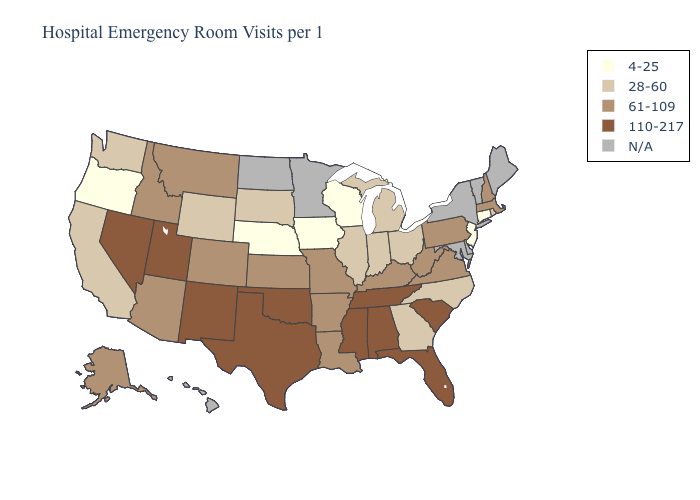What is the lowest value in the South?
Write a very short answer. 28-60. How many symbols are there in the legend?
Write a very short answer. 5. Name the states that have a value in the range 61-109?
Quick response, please. Alaska, Arizona, Arkansas, Colorado, Idaho, Kansas, Kentucky, Louisiana, Massachusetts, Missouri, Montana, New Hampshire, Pennsylvania, Virginia, West Virginia. Among the states that border Missouri , which have the lowest value?
Write a very short answer. Iowa, Nebraska. Does Pennsylvania have the highest value in the Northeast?
Be succinct. Yes. What is the value of California?
Write a very short answer. 28-60. Is the legend a continuous bar?
Write a very short answer. No. Name the states that have a value in the range N/A?
Quick response, please. Delaware, Hawaii, Maine, Maryland, Minnesota, New York, North Dakota, Vermont. What is the highest value in the USA?
Concise answer only. 110-217. Name the states that have a value in the range 61-109?
Answer briefly. Alaska, Arizona, Arkansas, Colorado, Idaho, Kansas, Kentucky, Louisiana, Massachusetts, Missouri, Montana, New Hampshire, Pennsylvania, Virginia, West Virginia. Name the states that have a value in the range 110-217?
Give a very brief answer. Alabama, Florida, Mississippi, Nevada, New Mexico, Oklahoma, South Carolina, Tennessee, Texas, Utah. Name the states that have a value in the range N/A?
Give a very brief answer. Delaware, Hawaii, Maine, Maryland, Minnesota, New York, North Dakota, Vermont. Does New Mexico have the highest value in the USA?
Quick response, please. Yes. What is the lowest value in states that border New Hampshire?
Give a very brief answer. 61-109. 